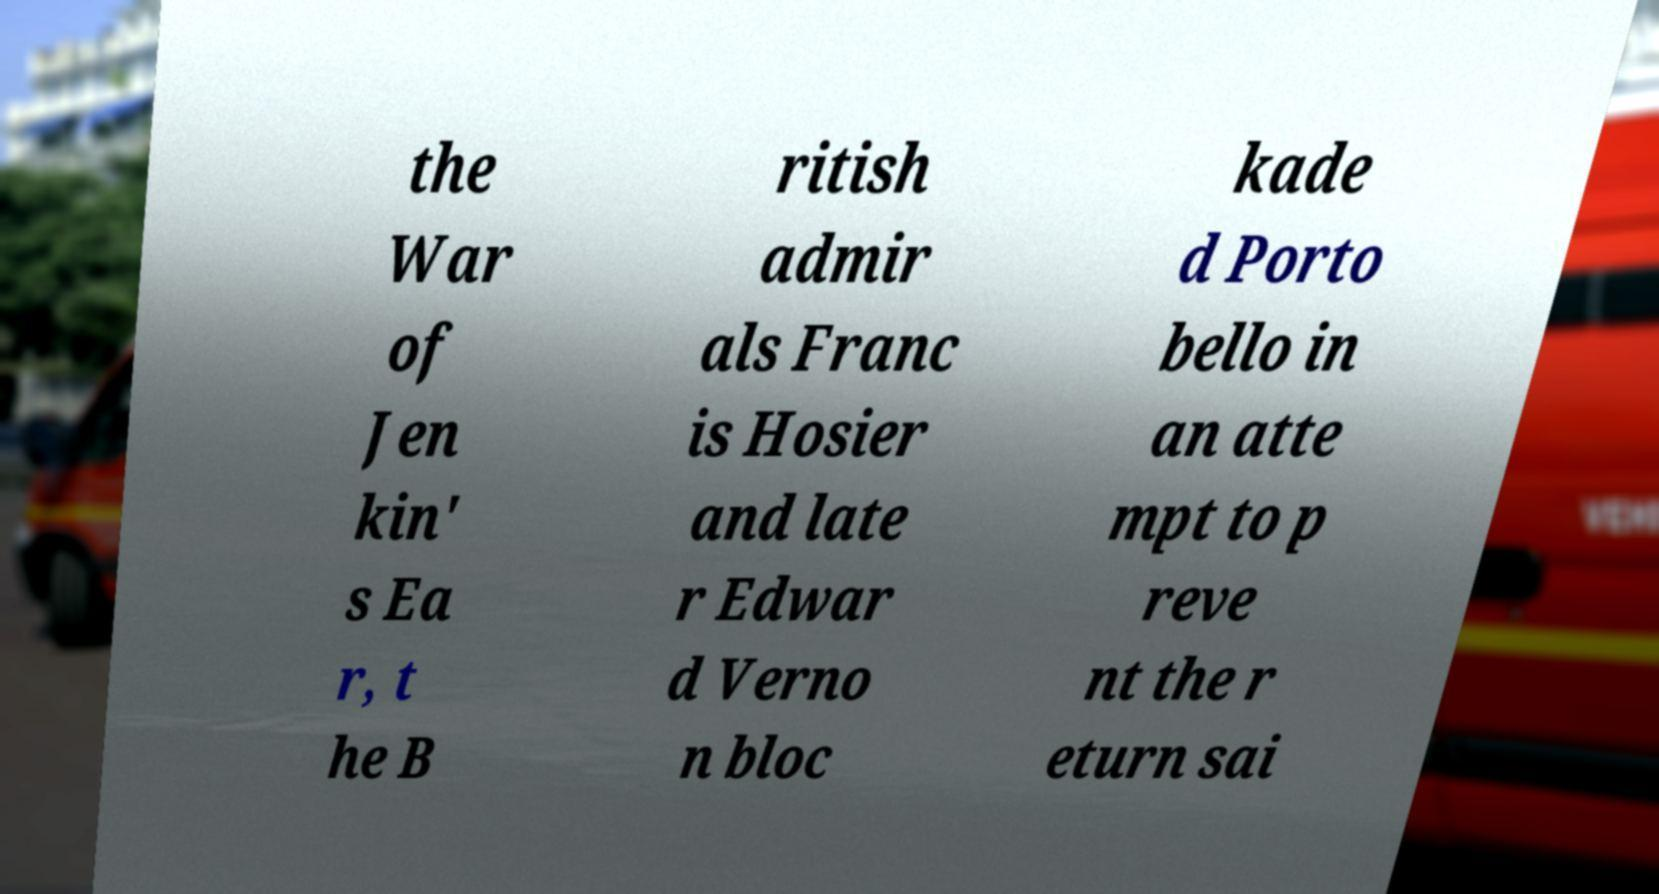For documentation purposes, I need the text within this image transcribed. Could you provide that? the War of Jen kin' s Ea r, t he B ritish admir als Franc is Hosier and late r Edwar d Verno n bloc kade d Porto bello in an atte mpt to p reve nt the r eturn sai 